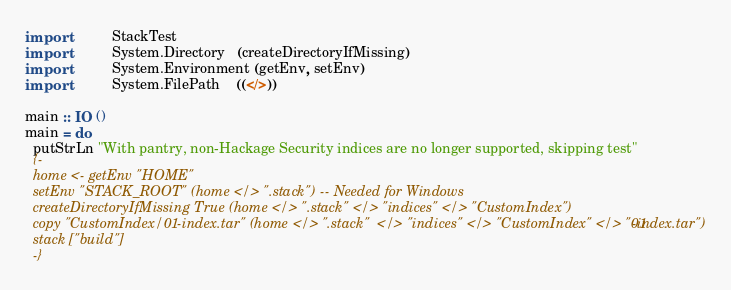<code> <loc_0><loc_0><loc_500><loc_500><_Haskell_>import           StackTest
import           System.Directory   (createDirectoryIfMissing)
import           System.Environment (getEnv, setEnv)
import           System.FilePath    ((</>))

main :: IO ()
main = do
  putStrLn "With pantry, non-Hackage Security indices are no longer supported, skipping test"
  {-
  home <- getEnv "HOME"
  setEnv "STACK_ROOT" (home </> ".stack") -- Needed for Windows
  createDirectoryIfMissing True (home </> ".stack" </> "indices" </> "CustomIndex")
  copy "CustomIndex/01-index.tar" (home </> ".stack"  </> "indices" </> "CustomIndex" </> "01-index.tar")
  stack ["build"]
  -}
</code> 